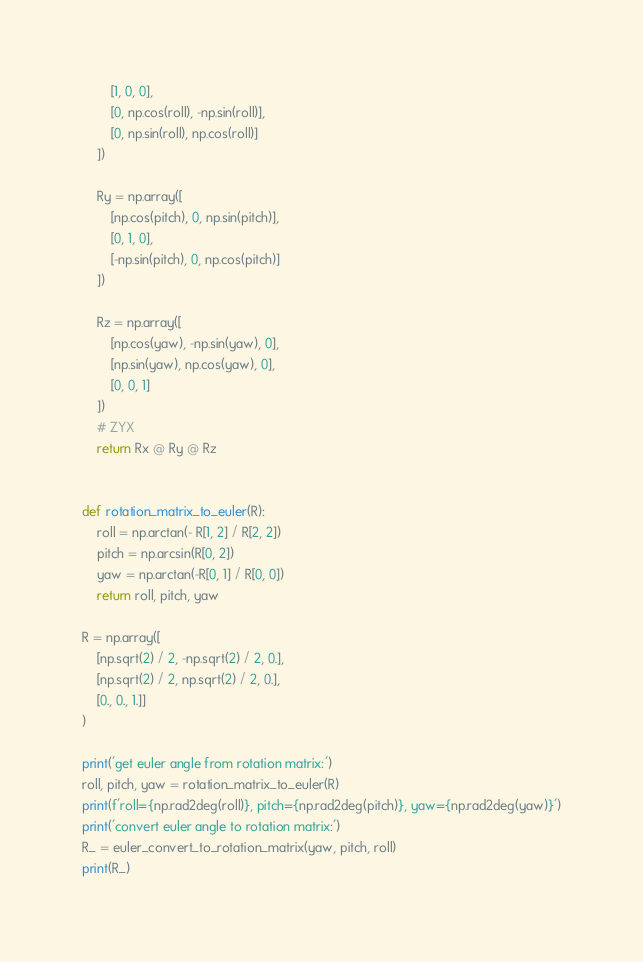Convert code to text. <code><loc_0><loc_0><loc_500><loc_500><_Python_>        [1, 0, 0],
        [0, np.cos(roll), -np.sin(roll)],
        [0, np.sin(roll), np.cos(roll)]
    ])

    Ry = np.array([
        [np.cos(pitch), 0, np.sin(pitch)],
        [0, 1, 0],
        [-np.sin(pitch), 0, np.cos(pitch)]
    ])

    Rz = np.array([
        [np.cos(yaw), -np.sin(yaw), 0],
        [np.sin(yaw), np.cos(yaw), 0],
        [0, 0, 1]
    ])
    # ZYX
    return Rx @ Ry @ Rz


def rotation_matrix_to_euler(R):
    roll = np.arctan(- R[1, 2] / R[2, 2])
    pitch = np.arcsin(R[0, 2])
    yaw = np.arctan(-R[0, 1] / R[0, 0])
    return roll, pitch, yaw

R = np.array([
    [np.sqrt(2) / 2, -np.sqrt(2) / 2, 0.],
    [np.sqrt(2) / 2, np.sqrt(2) / 2, 0.],
    [0., 0., 1.]]
)

print('get euler angle from rotation matrix:')
roll, pitch, yaw = rotation_matrix_to_euler(R)
print(f'roll={np.rad2deg(roll)}, pitch={np.rad2deg(pitch)}, yaw={np.rad2deg(yaw)}')
print('convert euler angle to rotation matrix:')
R_ = euler_convert_to_rotation_matrix(yaw, pitch, roll)
print(R_)</code> 